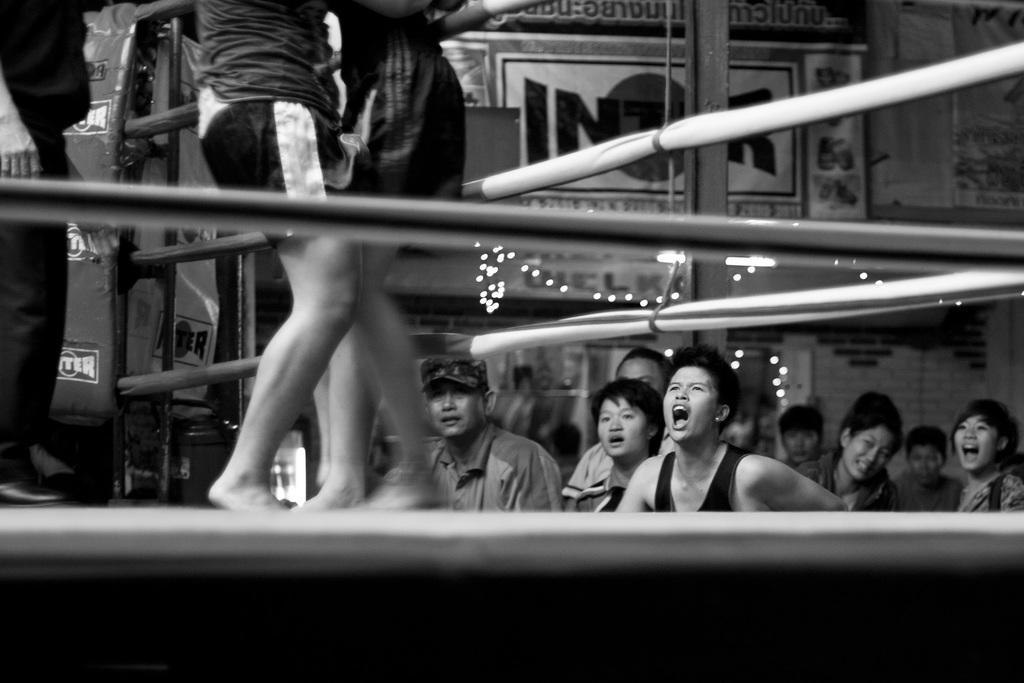Describe this image in one or two sentences. In this image we can see the wrestling stage. And we can see some audience members. And we can see a poster and some text is written on it. 